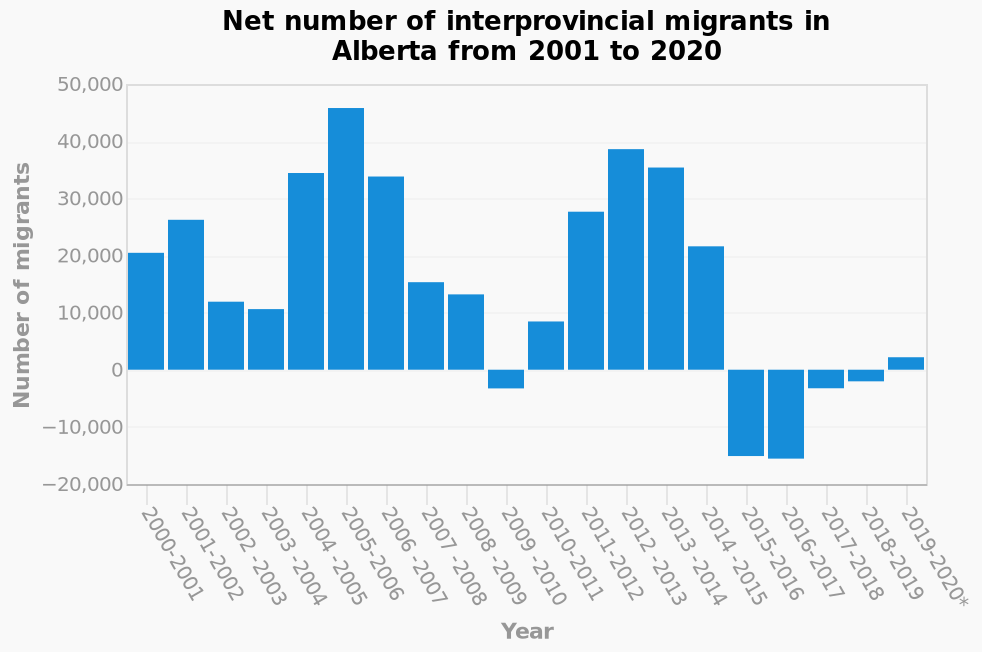<image>
What does the y-axis of the bar chart measure?  The y-axis measures the number of interprovincial migrants in Alberta. What time period does the bar chart cover? The bar chart covers the years from 2001 to 2020. please describe the details of the chart This is a bar chart titled Net number of interprovincial migrants in Alberta from 2001 to 2020. The x-axis measures Year while the y-axis plots Number of migrants. 